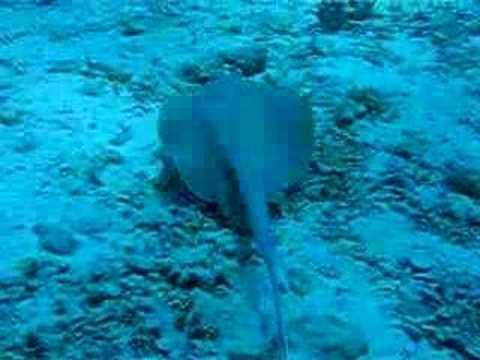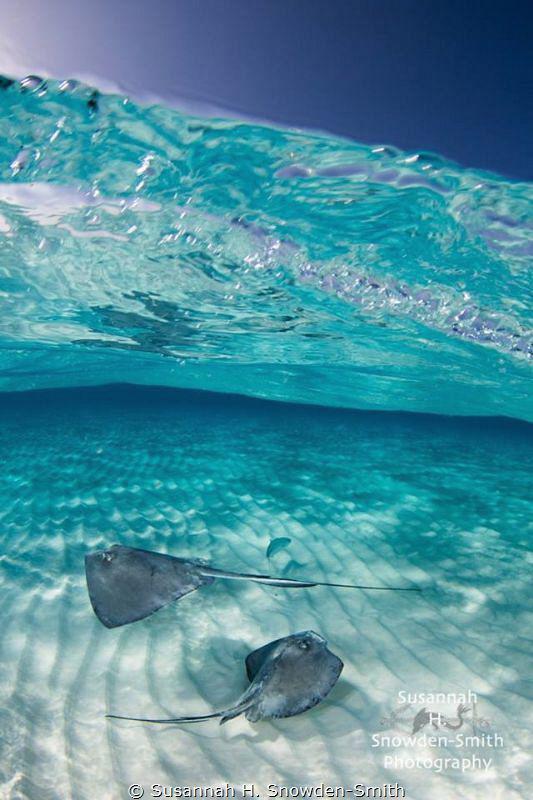The first image is the image on the left, the second image is the image on the right. Examine the images to the left and right. Is the description "At least one human is standig in water where stingray are swimming." accurate? Answer yes or no. No. The first image is the image on the left, the second image is the image on the right. Analyze the images presented: Is the assertion "There is a man, standing among the manta rays." valid? Answer yes or no. No. 